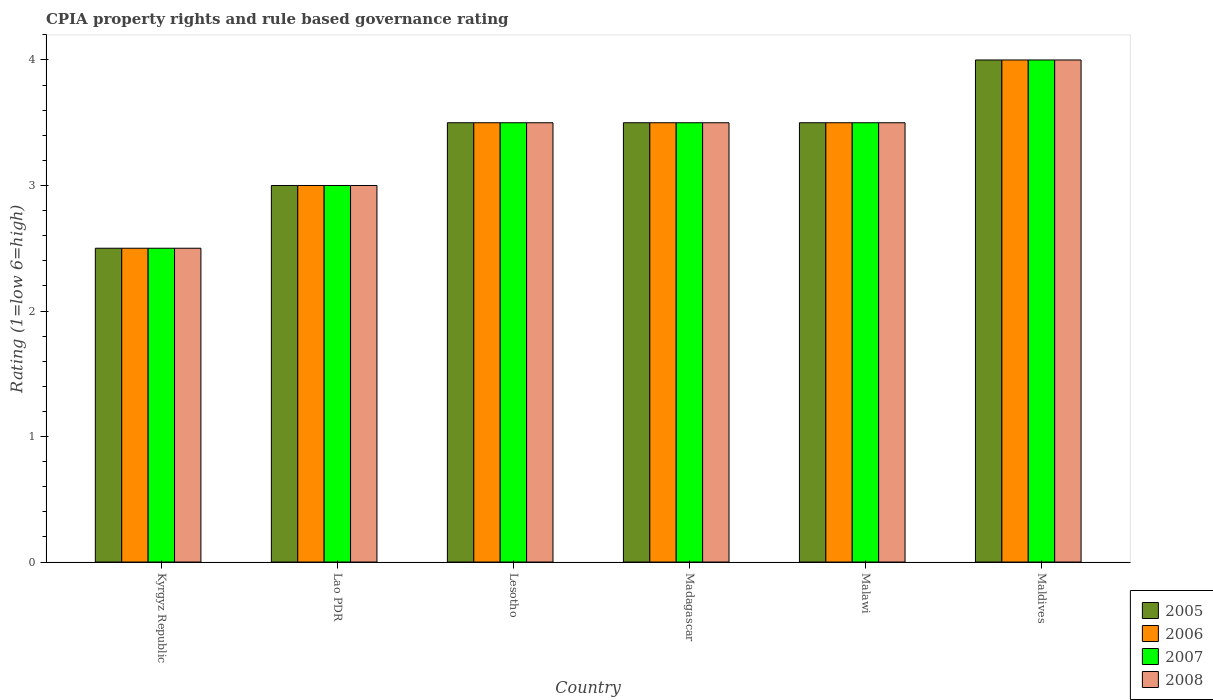How many different coloured bars are there?
Make the answer very short. 4. How many groups of bars are there?
Your answer should be compact. 6. Are the number of bars per tick equal to the number of legend labels?
Your answer should be very brief. Yes. How many bars are there on the 5th tick from the right?
Make the answer very short. 4. What is the label of the 5th group of bars from the left?
Give a very brief answer. Malawi. In how many cases, is the number of bars for a given country not equal to the number of legend labels?
Provide a short and direct response. 0. Across all countries, what is the maximum CPIA rating in 2008?
Your answer should be very brief. 4. In which country was the CPIA rating in 2008 maximum?
Your response must be concise. Maldives. In which country was the CPIA rating in 2008 minimum?
Make the answer very short. Kyrgyz Republic. What is the average CPIA rating in 2007 per country?
Your response must be concise. 3.33. In how many countries, is the CPIA rating in 2005 greater than 0.4?
Make the answer very short. 6. Is the CPIA rating in 2006 in Lao PDR less than that in Malawi?
Provide a succinct answer. Yes. What is the difference between the highest and the second highest CPIA rating in 2008?
Ensure brevity in your answer.  -0.5. What is the difference between the highest and the lowest CPIA rating in 2007?
Offer a terse response. 1.5. In how many countries, is the CPIA rating in 2007 greater than the average CPIA rating in 2007 taken over all countries?
Offer a very short reply. 4. Is the sum of the CPIA rating in 2008 in Lesotho and Madagascar greater than the maximum CPIA rating in 2007 across all countries?
Ensure brevity in your answer.  Yes. What does the 3rd bar from the left in Madagascar represents?
Ensure brevity in your answer.  2007. Is it the case that in every country, the sum of the CPIA rating in 2007 and CPIA rating in 2006 is greater than the CPIA rating in 2005?
Offer a very short reply. Yes. How many bars are there?
Provide a short and direct response. 24. Are all the bars in the graph horizontal?
Ensure brevity in your answer.  No. How many countries are there in the graph?
Offer a terse response. 6. What is the difference between two consecutive major ticks on the Y-axis?
Provide a short and direct response. 1. Are the values on the major ticks of Y-axis written in scientific E-notation?
Offer a very short reply. No. Does the graph contain any zero values?
Provide a short and direct response. No. How many legend labels are there?
Keep it short and to the point. 4. What is the title of the graph?
Give a very brief answer. CPIA property rights and rule based governance rating. Does "2005" appear as one of the legend labels in the graph?
Offer a very short reply. Yes. What is the label or title of the X-axis?
Your answer should be very brief. Country. What is the label or title of the Y-axis?
Your answer should be very brief. Rating (1=low 6=high). What is the Rating (1=low 6=high) in 2006 in Kyrgyz Republic?
Offer a terse response. 2.5. What is the Rating (1=low 6=high) in 2008 in Kyrgyz Republic?
Keep it short and to the point. 2.5. What is the Rating (1=low 6=high) of 2005 in Lao PDR?
Offer a terse response. 3. What is the Rating (1=low 6=high) of 2007 in Lao PDR?
Your answer should be very brief. 3. What is the Rating (1=low 6=high) in 2008 in Lao PDR?
Your response must be concise. 3. What is the Rating (1=low 6=high) of 2006 in Madagascar?
Provide a succinct answer. 3.5. What is the Rating (1=low 6=high) in 2008 in Madagascar?
Provide a succinct answer. 3.5. What is the Rating (1=low 6=high) of 2006 in Malawi?
Ensure brevity in your answer.  3.5. What is the Rating (1=low 6=high) in 2008 in Malawi?
Provide a succinct answer. 3.5. What is the Rating (1=low 6=high) in 2005 in Maldives?
Provide a short and direct response. 4. What is the Rating (1=low 6=high) of 2007 in Maldives?
Keep it short and to the point. 4. Across all countries, what is the maximum Rating (1=low 6=high) in 2005?
Ensure brevity in your answer.  4. Across all countries, what is the maximum Rating (1=low 6=high) in 2007?
Provide a short and direct response. 4. Across all countries, what is the maximum Rating (1=low 6=high) in 2008?
Give a very brief answer. 4. Across all countries, what is the minimum Rating (1=low 6=high) of 2006?
Keep it short and to the point. 2.5. Across all countries, what is the minimum Rating (1=low 6=high) of 2007?
Ensure brevity in your answer.  2.5. Across all countries, what is the minimum Rating (1=low 6=high) in 2008?
Keep it short and to the point. 2.5. What is the total Rating (1=low 6=high) of 2005 in the graph?
Ensure brevity in your answer.  20. What is the total Rating (1=low 6=high) in 2008 in the graph?
Your answer should be compact. 20. What is the difference between the Rating (1=low 6=high) of 2006 in Kyrgyz Republic and that in Lao PDR?
Make the answer very short. -0.5. What is the difference between the Rating (1=low 6=high) of 2007 in Kyrgyz Republic and that in Lao PDR?
Your answer should be very brief. -0.5. What is the difference between the Rating (1=low 6=high) of 2006 in Kyrgyz Republic and that in Lesotho?
Keep it short and to the point. -1. What is the difference between the Rating (1=low 6=high) of 2005 in Kyrgyz Republic and that in Madagascar?
Your response must be concise. -1. What is the difference between the Rating (1=low 6=high) in 2006 in Kyrgyz Republic and that in Madagascar?
Your answer should be very brief. -1. What is the difference between the Rating (1=low 6=high) in 2005 in Kyrgyz Republic and that in Malawi?
Your answer should be very brief. -1. What is the difference between the Rating (1=low 6=high) of 2007 in Kyrgyz Republic and that in Malawi?
Provide a succinct answer. -1. What is the difference between the Rating (1=low 6=high) in 2005 in Kyrgyz Republic and that in Maldives?
Your answer should be compact. -1.5. What is the difference between the Rating (1=low 6=high) of 2006 in Kyrgyz Republic and that in Maldives?
Provide a succinct answer. -1.5. What is the difference between the Rating (1=low 6=high) in 2007 in Kyrgyz Republic and that in Maldives?
Give a very brief answer. -1.5. What is the difference between the Rating (1=low 6=high) in 2008 in Kyrgyz Republic and that in Maldives?
Your response must be concise. -1.5. What is the difference between the Rating (1=low 6=high) in 2005 in Lao PDR and that in Lesotho?
Offer a very short reply. -0.5. What is the difference between the Rating (1=low 6=high) in 2008 in Lao PDR and that in Lesotho?
Offer a very short reply. -0.5. What is the difference between the Rating (1=low 6=high) in 2005 in Lao PDR and that in Madagascar?
Provide a short and direct response. -0.5. What is the difference between the Rating (1=low 6=high) in 2006 in Lao PDR and that in Madagascar?
Keep it short and to the point. -0.5. What is the difference between the Rating (1=low 6=high) of 2007 in Lao PDR and that in Madagascar?
Your response must be concise. -0.5. What is the difference between the Rating (1=low 6=high) in 2005 in Lao PDR and that in Malawi?
Keep it short and to the point. -0.5. What is the difference between the Rating (1=low 6=high) of 2006 in Lao PDR and that in Malawi?
Keep it short and to the point. -0.5. What is the difference between the Rating (1=low 6=high) in 2005 in Lesotho and that in Madagascar?
Provide a short and direct response. 0. What is the difference between the Rating (1=low 6=high) of 2007 in Lesotho and that in Madagascar?
Your answer should be compact. 0. What is the difference between the Rating (1=low 6=high) in 2005 in Lesotho and that in Malawi?
Ensure brevity in your answer.  0. What is the difference between the Rating (1=low 6=high) in 2007 in Lesotho and that in Malawi?
Offer a terse response. 0. What is the difference between the Rating (1=low 6=high) in 2008 in Lesotho and that in Malawi?
Make the answer very short. 0. What is the difference between the Rating (1=low 6=high) of 2005 in Lesotho and that in Maldives?
Your answer should be very brief. -0.5. What is the difference between the Rating (1=low 6=high) of 2005 in Madagascar and that in Malawi?
Your answer should be very brief. 0. What is the difference between the Rating (1=low 6=high) in 2006 in Madagascar and that in Malawi?
Your answer should be very brief. 0. What is the difference between the Rating (1=low 6=high) in 2007 in Madagascar and that in Malawi?
Make the answer very short. 0. What is the difference between the Rating (1=low 6=high) of 2008 in Madagascar and that in Malawi?
Keep it short and to the point. 0. What is the difference between the Rating (1=low 6=high) in 2005 in Madagascar and that in Maldives?
Give a very brief answer. -0.5. What is the difference between the Rating (1=low 6=high) of 2007 in Madagascar and that in Maldives?
Your response must be concise. -0.5. What is the difference between the Rating (1=low 6=high) of 2008 in Madagascar and that in Maldives?
Your answer should be compact. -0.5. What is the difference between the Rating (1=low 6=high) in 2005 in Malawi and that in Maldives?
Offer a very short reply. -0.5. What is the difference between the Rating (1=low 6=high) in 2006 in Malawi and that in Maldives?
Make the answer very short. -0.5. What is the difference between the Rating (1=low 6=high) of 2005 in Kyrgyz Republic and the Rating (1=low 6=high) of 2006 in Lao PDR?
Your answer should be compact. -0.5. What is the difference between the Rating (1=low 6=high) of 2005 in Kyrgyz Republic and the Rating (1=low 6=high) of 2008 in Lao PDR?
Give a very brief answer. -0.5. What is the difference between the Rating (1=low 6=high) of 2006 in Kyrgyz Republic and the Rating (1=low 6=high) of 2007 in Lao PDR?
Your answer should be compact. -0.5. What is the difference between the Rating (1=low 6=high) in 2006 in Kyrgyz Republic and the Rating (1=low 6=high) in 2008 in Lao PDR?
Your answer should be very brief. -0.5. What is the difference between the Rating (1=low 6=high) of 2005 in Kyrgyz Republic and the Rating (1=low 6=high) of 2008 in Lesotho?
Your response must be concise. -1. What is the difference between the Rating (1=low 6=high) of 2006 in Kyrgyz Republic and the Rating (1=low 6=high) of 2008 in Lesotho?
Make the answer very short. -1. What is the difference between the Rating (1=low 6=high) of 2005 in Kyrgyz Republic and the Rating (1=low 6=high) of 2007 in Madagascar?
Offer a terse response. -1. What is the difference between the Rating (1=low 6=high) of 2007 in Kyrgyz Republic and the Rating (1=low 6=high) of 2008 in Madagascar?
Your answer should be very brief. -1. What is the difference between the Rating (1=low 6=high) in 2005 in Kyrgyz Republic and the Rating (1=low 6=high) in 2006 in Malawi?
Give a very brief answer. -1. What is the difference between the Rating (1=low 6=high) of 2006 in Kyrgyz Republic and the Rating (1=low 6=high) of 2007 in Malawi?
Provide a short and direct response. -1. What is the difference between the Rating (1=low 6=high) in 2006 in Kyrgyz Republic and the Rating (1=low 6=high) in 2008 in Malawi?
Keep it short and to the point. -1. What is the difference between the Rating (1=low 6=high) of 2005 in Kyrgyz Republic and the Rating (1=low 6=high) of 2006 in Maldives?
Provide a succinct answer. -1.5. What is the difference between the Rating (1=low 6=high) of 2006 in Kyrgyz Republic and the Rating (1=low 6=high) of 2007 in Maldives?
Your answer should be compact. -1.5. What is the difference between the Rating (1=low 6=high) of 2006 in Kyrgyz Republic and the Rating (1=low 6=high) of 2008 in Maldives?
Make the answer very short. -1.5. What is the difference between the Rating (1=low 6=high) of 2005 in Lao PDR and the Rating (1=low 6=high) of 2006 in Lesotho?
Make the answer very short. -0.5. What is the difference between the Rating (1=low 6=high) in 2007 in Lao PDR and the Rating (1=low 6=high) in 2008 in Lesotho?
Your response must be concise. -0.5. What is the difference between the Rating (1=low 6=high) in 2005 in Lao PDR and the Rating (1=low 6=high) in 2006 in Madagascar?
Offer a terse response. -0.5. What is the difference between the Rating (1=low 6=high) in 2006 in Lao PDR and the Rating (1=low 6=high) in 2007 in Madagascar?
Make the answer very short. -0.5. What is the difference between the Rating (1=low 6=high) of 2006 in Lao PDR and the Rating (1=low 6=high) of 2008 in Madagascar?
Offer a terse response. -0.5. What is the difference between the Rating (1=low 6=high) in 2005 in Lao PDR and the Rating (1=low 6=high) in 2007 in Malawi?
Ensure brevity in your answer.  -0.5. What is the difference between the Rating (1=low 6=high) in 2005 in Lao PDR and the Rating (1=low 6=high) in 2008 in Malawi?
Ensure brevity in your answer.  -0.5. What is the difference between the Rating (1=low 6=high) of 2006 in Lao PDR and the Rating (1=low 6=high) of 2007 in Malawi?
Provide a succinct answer. -0.5. What is the difference between the Rating (1=low 6=high) in 2007 in Lao PDR and the Rating (1=low 6=high) in 2008 in Malawi?
Your response must be concise. -0.5. What is the difference between the Rating (1=low 6=high) of 2005 in Lao PDR and the Rating (1=low 6=high) of 2006 in Maldives?
Your answer should be compact. -1. What is the difference between the Rating (1=low 6=high) in 2005 in Lao PDR and the Rating (1=low 6=high) in 2007 in Maldives?
Your answer should be very brief. -1. What is the difference between the Rating (1=low 6=high) in 2005 in Lao PDR and the Rating (1=low 6=high) in 2008 in Maldives?
Your answer should be compact. -1. What is the difference between the Rating (1=low 6=high) of 2006 in Lao PDR and the Rating (1=low 6=high) of 2007 in Maldives?
Your answer should be compact. -1. What is the difference between the Rating (1=low 6=high) of 2006 in Lao PDR and the Rating (1=low 6=high) of 2008 in Maldives?
Your answer should be compact. -1. What is the difference between the Rating (1=low 6=high) of 2007 in Lao PDR and the Rating (1=low 6=high) of 2008 in Maldives?
Your answer should be compact. -1. What is the difference between the Rating (1=low 6=high) of 2005 in Lesotho and the Rating (1=low 6=high) of 2006 in Madagascar?
Keep it short and to the point. 0. What is the difference between the Rating (1=low 6=high) in 2006 in Lesotho and the Rating (1=low 6=high) in 2007 in Madagascar?
Keep it short and to the point. 0. What is the difference between the Rating (1=low 6=high) in 2006 in Lesotho and the Rating (1=low 6=high) in 2008 in Madagascar?
Give a very brief answer. 0. What is the difference between the Rating (1=low 6=high) of 2007 in Lesotho and the Rating (1=low 6=high) of 2008 in Madagascar?
Make the answer very short. 0. What is the difference between the Rating (1=low 6=high) in 2005 in Lesotho and the Rating (1=low 6=high) in 2006 in Malawi?
Provide a short and direct response. 0. What is the difference between the Rating (1=low 6=high) in 2005 in Lesotho and the Rating (1=low 6=high) in 2007 in Malawi?
Provide a succinct answer. 0. What is the difference between the Rating (1=low 6=high) of 2006 in Lesotho and the Rating (1=low 6=high) of 2007 in Malawi?
Your answer should be compact. 0. What is the difference between the Rating (1=low 6=high) of 2006 in Lesotho and the Rating (1=low 6=high) of 2008 in Malawi?
Provide a short and direct response. 0. What is the difference between the Rating (1=low 6=high) in 2005 in Lesotho and the Rating (1=low 6=high) in 2006 in Maldives?
Provide a succinct answer. -0.5. What is the difference between the Rating (1=low 6=high) of 2005 in Lesotho and the Rating (1=low 6=high) of 2008 in Maldives?
Your answer should be very brief. -0.5. What is the difference between the Rating (1=low 6=high) of 2006 in Lesotho and the Rating (1=low 6=high) of 2007 in Maldives?
Your answer should be compact. -0.5. What is the difference between the Rating (1=low 6=high) in 2006 in Lesotho and the Rating (1=low 6=high) in 2008 in Maldives?
Keep it short and to the point. -0.5. What is the difference between the Rating (1=low 6=high) in 2007 in Lesotho and the Rating (1=low 6=high) in 2008 in Maldives?
Keep it short and to the point. -0.5. What is the difference between the Rating (1=low 6=high) of 2005 in Madagascar and the Rating (1=low 6=high) of 2007 in Malawi?
Your answer should be compact. 0. What is the difference between the Rating (1=low 6=high) of 2005 in Madagascar and the Rating (1=low 6=high) of 2008 in Malawi?
Give a very brief answer. 0. What is the difference between the Rating (1=low 6=high) in 2006 in Madagascar and the Rating (1=low 6=high) in 2008 in Malawi?
Offer a very short reply. 0. What is the difference between the Rating (1=low 6=high) of 2005 in Madagascar and the Rating (1=low 6=high) of 2007 in Maldives?
Your answer should be very brief. -0.5. What is the difference between the Rating (1=low 6=high) in 2005 in Madagascar and the Rating (1=low 6=high) in 2008 in Maldives?
Give a very brief answer. -0.5. What is the difference between the Rating (1=low 6=high) of 2006 in Madagascar and the Rating (1=low 6=high) of 2007 in Maldives?
Your answer should be very brief. -0.5. What is the difference between the Rating (1=low 6=high) in 2007 in Madagascar and the Rating (1=low 6=high) in 2008 in Maldives?
Offer a terse response. -0.5. What is the difference between the Rating (1=low 6=high) in 2005 in Malawi and the Rating (1=low 6=high) in 2006 in Maldives?
Your response must be concise. -0.5. What is the difference between the Rating (1=low 6=high) of 2007 in Malawi and the Rating (1=low 6=high) of 2008 in Maldives?
Give a very brief answer. -0.5. What is the average Rating (1=low 6=high) in 2005 per country?
Ensure brevity in your answer.  3.33. What is the average Rating (1=low 6=high) of 2006 per country?
Make the answer very short. 3.33. What is the difference between the Rating (1=low 6=high) in 2005 and Rating (1=low 6=high) in 2007 in Kyrgyz Republic?
Make the answer very short. 0. What is the difference between the Rating (1=low 6=high) of 2005 and Rating (1=low 6=high) of 2008 in Kyrgyz Republic?
Your answer should be very brief. 0. What is the difference between the Rating (1=low 6=high) in 2007 and Rating (1=low 6=high) in 2008 in Kyrgyz Republic?
Make the answer very short. 0. What is the difference between the Rating (1=low 6=high) in 2005 and Rating (1=low 6=high) in 2006 in Lao PDR?
Make the answer very short. 0. What is the difference between the Rating (1=low 6=high) of 2005 and Rating (1=low 6=high) of 2008 in Lao PDR?
Your response must be concise. 0. What is the difference between the Rating (1=low 6=high) of 2006 and Rating (1=low 6=high) of 2007 in Lao PDR?
Provide a succinct answer. 0. What is the difference between the Rating (1=low 6=high) in 2006 and Rating (1=low 6=high) in 2008 in Lao PDR?
Keep it short and to the point. 0. What is the difference between the Rating (1=low 6=high) in 2005 and Rating (1=low 6=high) in 2006 in Lesotho?
Give a very brief answer. 0. What is the difference between the Rating (1=low 6=high) of 2006 and Rating (1=low 6=high) of 2007 in Lesotho?
Your answer should be very brief. 0. What is the difference between the Rating (1=low 6=high) of 2006 and Rating (1=low 6=high) of 2008 in Lesotho?
Offer a terse response. 0. What is the difference between the Rating (1=low 6=high) of 2005 and Rating (1=low 6=high) of 2007 in Madagascar?
Give a very brief answer. 0. What is the difference between the Rating (1=low 6=high) of 2005 and Rating (1=low 6=high) of 2008 in Madagascar?
Offer a very short reply. 0. What is the difference between the Rating (1=low 6=high) of 2006 and Rating (1=low 6=high) of 2008 in Madagascar?
Make the answer very short. 0. What is the difference between the Rating (1=low 6=high) in 2005 and Rating (1=low 6=high) in 2006 in Maldives?
Keep it short and to the point. 0. What is the difference between the Rating (1=low 6=high) in 2005 and Rating (1=low 6=high) in 2007 in Maldives?
Ensure brevity in your answer.  0. What is the difference between the Rating (1=low 6=high) of 2005 and Rating (1=low 6=high) of 2008 in Maldives?
Give a very brief answer. 0. What is the difference between the Rating (1=low 6=high) in 2006 and Rating (1=low 6=high) in 2007 in Maldives?
Give a very brief answer. 0. What is the difference between the Rating (1=low 6=high) of 2006 and Rating (1=low 6=high) of 2008 in Maldives?
Your answer should be very brief. 0. What is the ratio of the Rating (1=low 6=high) of 2005 in Kyrgyz Republic to that in Lao PDR?
Offer a terse response. 0.83. What is the ratio of the Rating (1=low 6=high) in 2006 in Kyrgyz Republic to that in Lao PDR?
Your response must be concise. 0.83. What is the ratio of the Rating (1=low 6=high) in 2007 in Kyrgyz Republic to that in Lao PDR?
Offer a terse response. 0.83. What is the ratio of the Rating (1=low 6=high) in 2008 in Kyrgyz Republic to that in Lao PDR?
Offer a very short reply. 0.83. What is the ratio of the Rating (1=low 6=high) in 2005 in Kyrgyz Republic to that in Lesotho?
Your answer should be compact. 0.71. What is the ratio of the Rating (1=low 6=high) in 2006 in Kyrgyz Republic to that in Lesotho?
Keep it short and to the point. 0.71. What is the ratio of the Rating (1=low 6=high) of 2007 in Kyrgyz Republic to that in Lesotho?
Keep it short and to the point. 0.71. What is the ratio of the Rating (1=low 6=high) in 2008 in Kyrgyz Republic to that in Lesotho?
Your answer should be compact. 0.71. What is the ratio of the Rating (1=low 6=high) of 2005 in Kyrgyz Republic to that in Madagascar?
Give a very brief answer. 0.71. What is the ratio of the Rating (1=low 6=high) of 2008 in Kyrgyz Republic to that in Madagascar?
Give a very brief answer. 0.71. What is the ratio of the Rating (1=low 6=high) of 2006 in Kyrgyz Republic to that in Maldives?
Your answer should be very brief. 0.62. What is the ratio of the Rating (1=low 6=high) of 2007 in Lao PDR to that in Lesotho?
Offer a terse response. 0.86. What is the ratio of the Rating (1=low 6=high) in 2006 in Lao PDR to that in Madagascar?
Offer a terse response. 0.86. What is the ratio of the Rating (1=low 6=high) in 2007 in Lao PDR to that in Madagascar?
Make the answer very short. 0.86. What is the ratio of the Rating (1=low 6=high) in 2005 in Lao PDR to that in Malawi?
Give a very brief answer. 0.86. What is the ratio of the Rating (1=low 6=high) in 2006 in Lao PDR to that in Malawi?
Keep it short and to the point. 0.86. What is the ratio of the Rating (1=low 6=high) of 2008 in Lao PDR to that in Malawi?
Your answer should be compact. 0.86. What is the ratio of the Rating (1=low 6=high) of 2005 in Lao PDR to that in Maldives?
Your answer should be compact. 0.75. What is the ratio of the Rating (1=low 6=high) of 2007 in Lao PDR to that in Maldives?
Provide a short and direct response. 0.75. What is the ratio of the Rating (1=low 6=high) of 2008 in Lao PDR to that in Maldives?
Your response must be concise. 0.75. What is the ratio of the Rating (1=low 6=high) of 2007 in Lesotho to that in Madagascar?
Offer a terse response. 1. What is the ratio of the Rating (1=low 6=high) in 2008 in Lesotho to that in Madagascar?
Your answer should be very brief. 1. What is the ratio of the Rating (1=low 6=high) in 2005 in Lesotho to that in Malawi?
Give a very brief answer. 1. What is the ratio of the Rating (1=low 6=high) in 2006 in Lesotho to that in Malawi?
Your response must be concise. 1. What is the ratio of the Rating (1=low 6=high) in 2006 in Lesotho to that in Maldives?
Offer a terse response. 0.88. What is the ratio of the Rating (1=low 6=high) of 2005 in Madagascar to that in Malawi?
Keep it short and to the point. 1. What is the ratio of the Rating (1=low 6=high) in 2007 in Madagascar to that in Malawi?
Provide a short and direct response. 1. What is the ratio of the Rating (1=low 6=high) of 2006 in Madagascar to that in Maldives?
Give a very brief answer. 0.88. What is the ratio of the Rating (1=low 6=high) of 2008 in Madagascar to that in Maldives?
Your response must be concise. 0.88. What is the ratio of the Rating (1=low 6=high) of 2005 in Malawi to that in Maldives?
Make the answer very short. 0.88. What is the ratio of the Rating (1=low 6=high) in 2006 in Malawi to that in Maldives?
Your answer should be very brief. 0.88. What is the ratio of the Rating (1=low 6=high) in 2008 in Malawi to that in Maldives?
Offer a very short reply. 0.88. What is the difference between the highest and the second highest Rating (1=low 6=high) in 2005?
Your answer should be compact. 0.5. What is the difference between the highest and the second highest Rating (1=low 6=high) of 2007?
Your answer should be very brief. 0.5. What is the difference between the highest and the second highest Rating (1=low 6=high) in 2008?
Your answer should be very brief. 0.5. What is the difference between the highest and the lowest Rating (1=low 6=high) in 2006?
Offer a terse response. 1.5. 